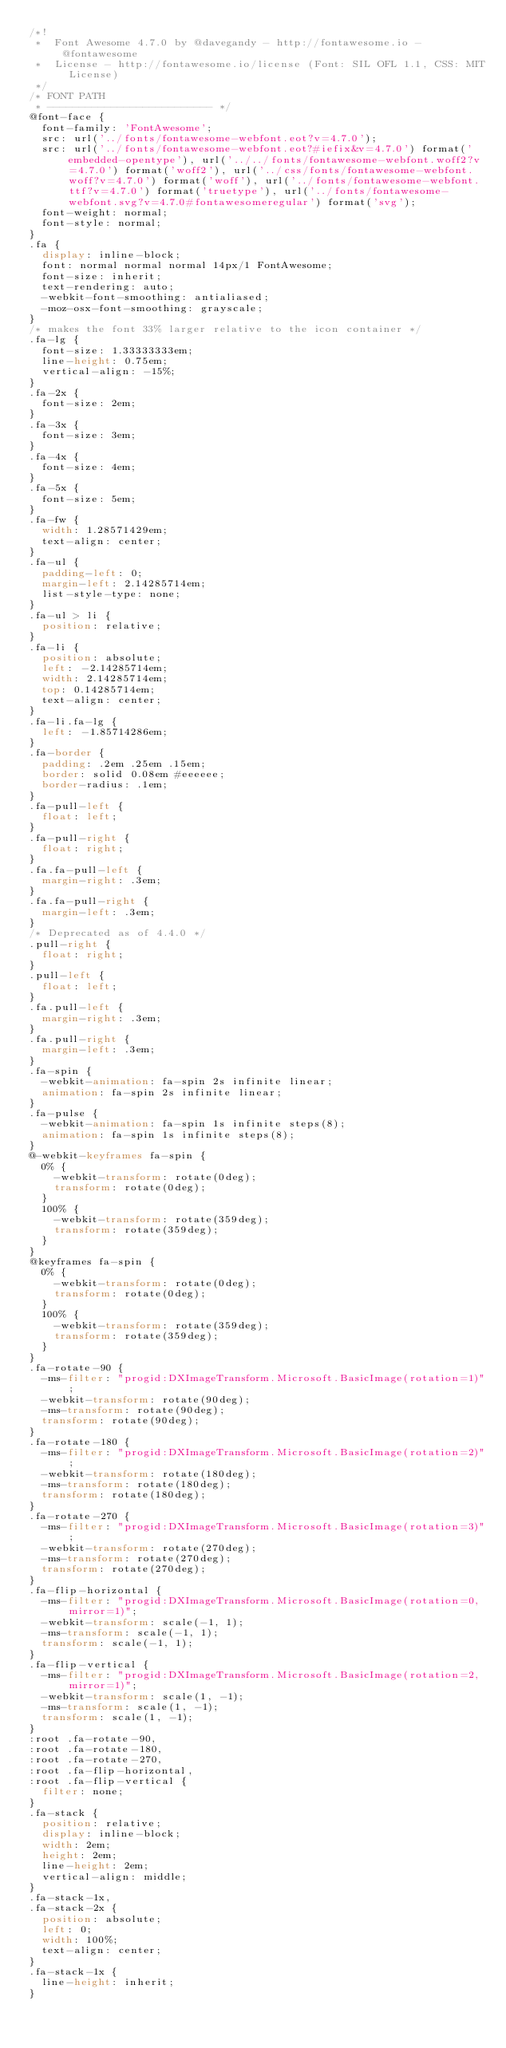<code> <loc_0><loc_0><loc_500><loc_500><_CSS_>/*!
 *  Font Awesome 4.7.0 by @davegandy - http://fontawesome.io - @fontawesome
 *  License - http://fontawesome.io/license (Font: SIL OFL 1.1, CSS: MIT License)
 */
/* FONT PATH
 * -------------------------- */
@font-face {
  font-family: 'FontAwesome';
  src: url('../fonts/fontawesome-webfont.eot?v=4.7.0');
  src: url('../fonts/fontawesome-webfont.eot?#iefix&v=4.7.0') format('embedded-opentype'), url('../../fonts/fontawesome-webfont.woff2?v=4.7.0') format('woff2'), url('../css/fonts/fontawesome-webfont.woff?v=4.7.0') format('woff'), url('../fonts/fontawesome-webfont.ttf?v=4.7.0') format('truetype'), url('../fonts/fontawesome-webfont.svg?v=4.7.0#fontawesomeregular') format('svg');
  font-weight: normal;
  font-style: normal;
}
.fa {
  display: inline-block;
  font: normal normal normal 14px/1 FontAwesome;
  font-size: inherit;
  text-rendering: auto;
  -webkit-font-smoothing: antialiased;
  -moz-osx-font-smoothing: grayscale;
}
/* makes the font 33% larger relative to the icon container */
.fa-lg {
  font-size: 1.33333333em;
  line-height: 0.75em;
  vertical-align: -15%;
}
.fa-2x {
  font-size: 2em;
}
.fa-3x {
  font-size: 3em;
}
.fa-4x {
  font-size: 4em;
}
.fa-5x {
  font-size: 5em;
}
.fa-fw {
  width: 1.28571429em;
  text-align: center;
}
.fa-ul {
  padding-left: 0;
  margin-left: 2.14285714em;
  list-style-type: none;
}
.fa-ul > li {
  position: relative;
}
.fa-li {
  position: absolute;
  left: -2.14285714em;
  width: 2.14285714em;
  top: 0.14285714em;
  text-align: center;
}
.fa-li.fa-lg {
  left: -1.85714286em;
}
.fa-border {
  padding: .2em .25em .15em;
  border: solid 0.08em #eeeeee;
  border-radius: .1em;
}
.fa-pull-left {
  float: left;
}
.fa-pull-right {
  float: right;
}
.fa.fa-pull-left {
  margin-right: .3em;
}
.fa.fa-pull-right {
  margin-left: .3em;
}
/* Deprecated as of 4.4.0 */
.pull-right {
  float: right;
}
.pull-left {
  float: left;
}
.fa.pull-left {
  margin-right: .3em;
}
.fa.pull-right {
  margin-left: .3em;
}
.fa-spin {
  -webkit-animation: fa-spin 2s infinite linear;
  animation: fa-spin 2s infinite linear;
}
.fa-pulse {
  -webkit-animation: fa-spin 1s infinite steps(8);
  animation: fa-spin 1s infinite steps(8);
}
@-webkit-keyframes fa-spin {
  0% {
    -webkit-transform: rotate(0deg);
    transform: rotate(0deg);
  }
  100% {
    -webkit-transform: rotate(359deg);
    transform: rotate(359deg);
  }
}
@keyframes fa-spin {
  0% {
    -webkit-transform: rotate(0deg);
    transform: rotate(0deg);
  }
  100% {
    -webkit-transform: rotate(359deg);
    transform: rotate(359deg);
  }
}
.fa-rotate-90 {
  -ms-filter: "progid:DXImageTransform.Microsoft.BasicImage(rotation=1)";
  -webkit-transform: rotate(90deg);
  -ms-transform: rotate(90deg);
  transform: rotate(90deg);
}
.fa-rotate-180 {
  -ms-filter: "progid:DXImageTransform.Microsoft.BasicImage(rotation=2)";
  -webkit-transform: rotate(180deg);
  -ms-transform: rotate(180deg);
  transform: rotate(180deg);
}
.fa-rotate-270 {
  -ms-filter: "progid:DXImageTransform.Microsoft.BasicImage(rotation=3)";
  -webkit-transform: rotate(270deg);
  -ms-transform: rotate(270deg);
  transform: rotate(270deg);
}
.fa-flip-horizontal {
  -ms-filter: "progid:DXImageTransform.Microsoft.BasicImage(rotation=0, mirror=1)";
  -webkit-transform: scale(-1, 1);
  -ms-transform: scale(-1, 1);
  transform: scale(-1, 1);
}
.fa-flip-vertical {
  -ms-filter: "progid:DXImageTransform.Microsoft.BasicImage(rotation=2, mirror=1)";
  -webkit-transform: scale(1, -1);
  -ms-transform: scale(1, -1);
  transform: scale(1, -1);
}
:root .fa-rotate-90,
:root .fa-rotate-180,
:root .fa-rotate-270,
:root .fa-flip-horizontal,
:root .fa-flip-vertical {
  filter: none;
}
.fa-stack {
  position: relative;
  display: inline-block;
  width: 2em;
  height: 2em;
  line-height: 2em;
  vertical-align: middle;
}
.fa-stack-1x,
.fa-stack-2x {
  position: absolute;
  left: 0;
  width: 100%;
  text-align: center;
}
.fa-stack-1x {
  line-height: inherit;
}</code> 